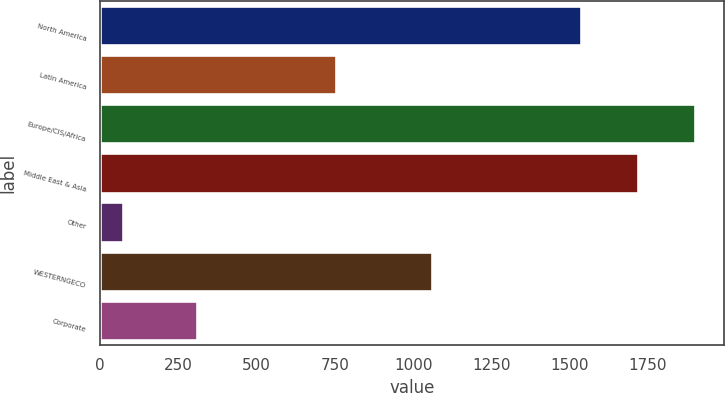Convert chart to OTSL. <chart><loc_0><loc_0><loc_500><loc_500><bar_chart><fcel>North America<fcel>Latin America<fcel>Europe/CIS/Africa<fcel>Middle East & Asia<fcel>Other<fcel>WESTERNGECO<fcel>Corporate<nl><fcel>1537<fcel>755<fcel>1899<fcel>1718<fcel>75<fcel>1060<fcel>311<nl></chart> 